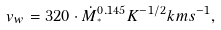Convert formula to latex. <formula><loc_0><loc_0><loc_500><loc_500>v _ { w } = 3 2 0 \cdot \dot { M } _ { ^ { * } } ^ { 0 . 1 4 5 } K ^ { - 1 / 2 } k m s ^ { - 1 } ,</formula> 